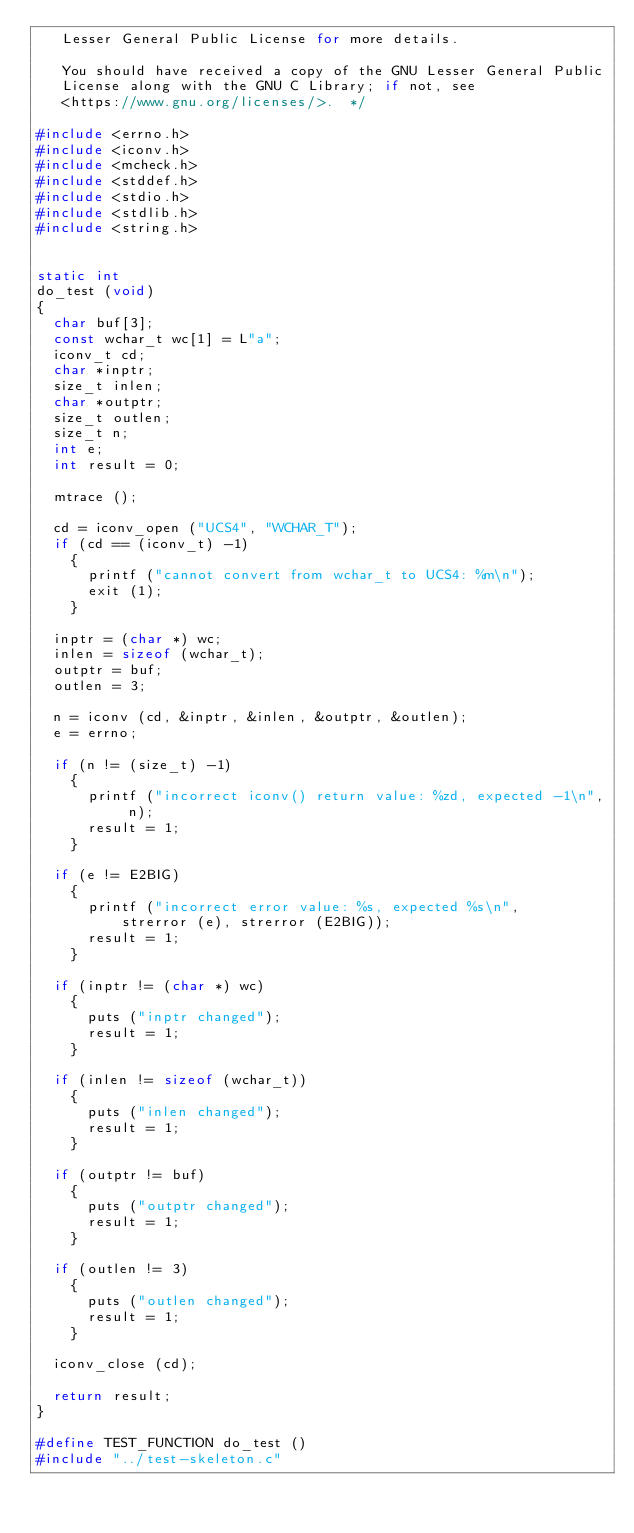<code> <loc_0><loc_0><loc_500><loc_500><_C_>   Lesser General Public License for more details.

   You should have received a copy of the GNU Lesser General Public
   License along with the GNU C Library; if not, see
   <https://www.gnu.org/licenses/>.  */

#include <errno.h>
#include <iconv.h>
#include <mcheck.h>
#include <stddef.h>
#include <stdio.h>
#include <stdlib.h>
#include <string.h>


static int
do_test (void)
{
  char buf[3];
  const wchar_t wc[1] = L"a";
  iconv_t cd;
  char *inptr;
  size_t inlen;
  char *outptr;
  size_t outlen;
  size_t n;
  int e;
  int result = 0;

  mtrace ();

  cd = iconv_open ("UCS4", "WCHAR_T");
  if (cd == (iconv_t) -1)
    {
      printf ("cannot convert from wchar_t to UCS4: %m\n");
      exit (1);
    }

  inptr = (char *) wc;
  inlen = sizeof (wchar_t);
  outptr = buf;
  outlen = 3;

  n = iconv (cd, &inptr, &inlen, &outptr, &outlen);
  e = errno;

  if (n != (size_t) -1)
    {
      printf ("incorrect iconv() return value: %zd, expected -1\n", n);
      result = 1;
    }

  if (e != E2BIG)
    {
      printf ("incorrect error value: %s, expected %s\n",
	      strerror (e), strerror (E2BIG));
      result = 1;
    }

  if (inptr != (char *) wc)
    {
      puts ("inptr changed");
      result = 1;
    }

  if (inlen != sizeof (wchar_t))
    {
      puts ("inlen changed");
      result = 1;
    }

  if (outptr != buf)
    {
      puts ("outptr changed");
      result = 1;
    }

  if (outlen != 3)
    {
      puts ("outlen changed");
      result = 1;
    }

  iconv_close (cd);

  return result;
}

#define TEST_FUNCTION do_test ()
#include "../test-skeleton.c"
</code> 